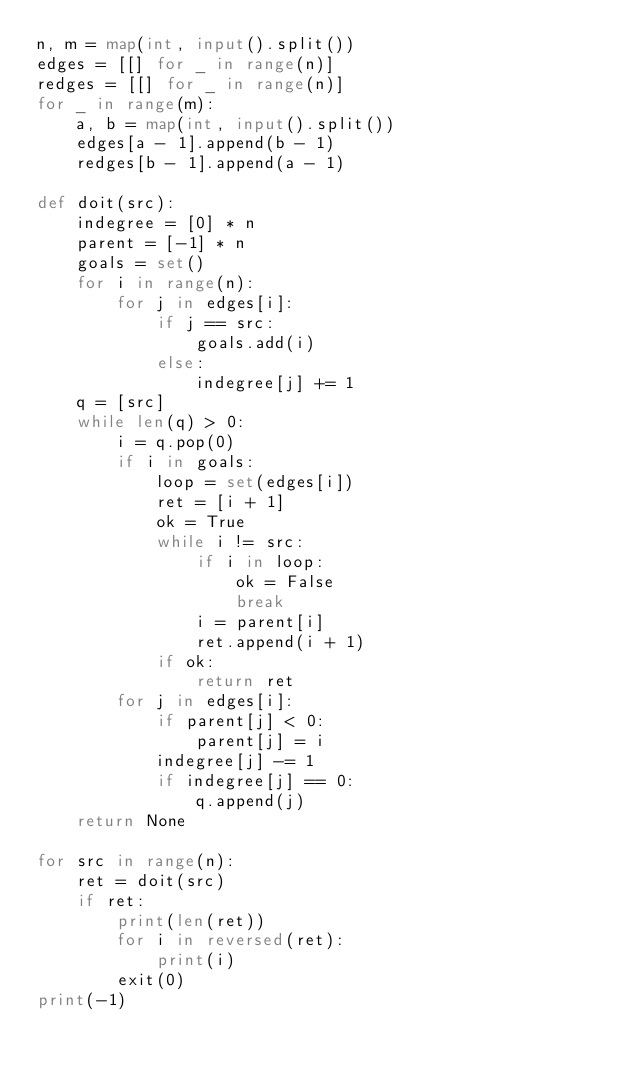<code> <loc_0><loc_0><loc_500><loc_500><_Python_>n, m = map(int, input().split())
edges = [[] for _ in range(n)]
redges = [[] for _ in range(n)]
for _ in range(m):
    a, b = map(int, input().split())
    edges[a - 1].append(b - 1)
    redges[b - 1].append(a - 1)

def doit(src):
    indegree = [0] * n
    parent = [-1] * n
    goals = set()
    for i in range(n):
        for j in edges[i]:
            if j == src:
                goals.add(i)
            else:
                indegree[j] += 1
    q = [src]
    while len(q) > 0:
        i = q.pop(0)
        if i in goals:
            loop = set(edges[i])
            ret = [i + 1]
            ok = True
            while i != src:
                if i in loop:
                    ok = False
                    break
                i = parent[i]
                ret.append(i + 1)
            if ok:
                return ret
        for j in edges[i]:
            if parent[j] < 0:
                parent[j] = i
            indegree[j] -= 1
            if indegree[j] == 0:
                q.append(j)
    return None

for src in range(n):
    ret = doit(src)
    if ret:
        print(len(ret))
        for i in reversed(ret):
            print(i)
        exit(0)
print(-1)
</code> 